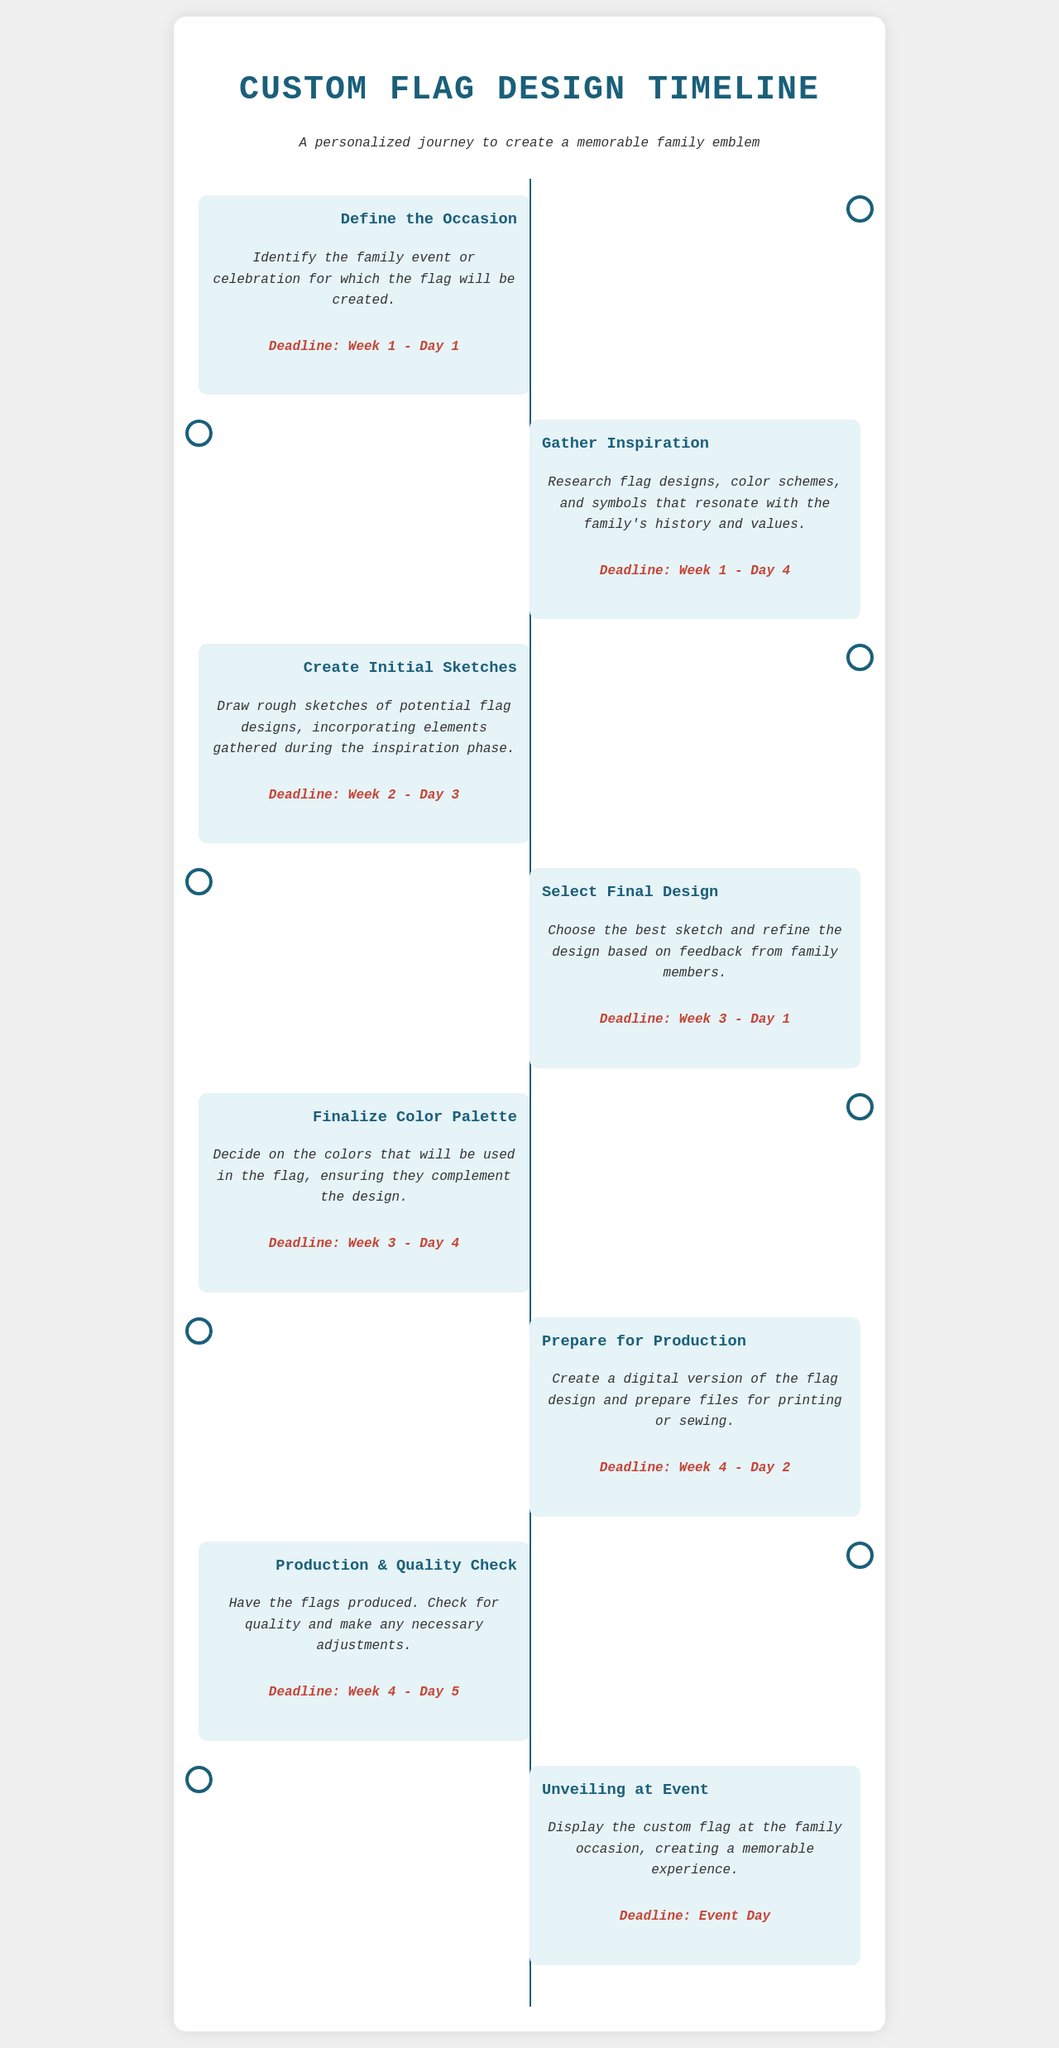What is the first task in the timeline? The first task listed in the timeline is "Define the Occasion."
Answer: Define the Occasion By which day must the initial sketches be completed? The deadline for the initial sketches is specified in the document as "Week 2 - Day 3."
Answer: Week 2 - Day 3 What is the deadline for selecting the final design? The document states that the final design must be selected by "Week 3 - Day 1."
Answer: Week 3 - Day 1 How many days are allocated for gathering inspiration? The task "Gather Inspiration" has a deadline of "Week 1 - Day 4," meaning there are 4 days allocated.
Answer: 4 days Which milestone involves a quality check? The milestone that includes a quality check is "Production & Quality Check."
Answer: Production & Quality Check What color scheme task is scheduled before production? The task that involves colors is "Finalize Color Palette," which is necessary before production.
Answer: Finalize Color Palette On which day is the flag scheduled to be unveiled? The document indicates that the flag is to be unveiled on "Event Day."
Answer: Event Day How many total milestones are there in the timeline? By counting each milestone listed in the document, there are a total of 8 milestones.
Answer: 8 milestones What is the purpose of preparing for production? The purpose is to create a digital version of the flag design and prepare files for printing or sewing.
Answer: Create a digital version of the flag design and prepare files for printing or sewing 